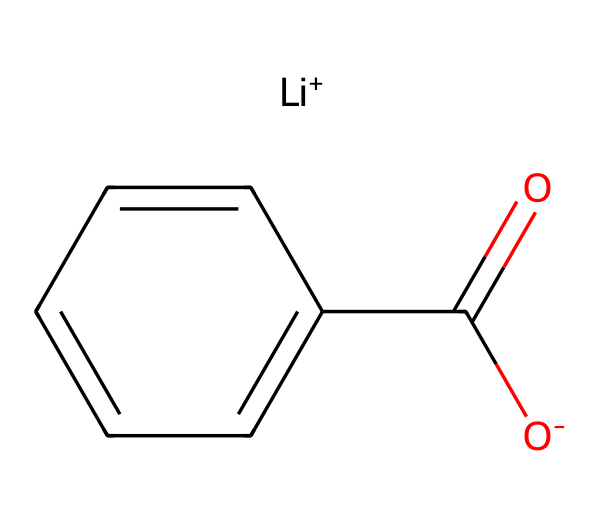How many lithium atoms are present in this structure? The SMILES notation directly indicates the presence of one lithium atom through the symbol [Li+]. There are no other lithium symbols indicated, confirming just one lithium in the structure.
Answer: one What is the oxidation state of lithium in this compound? In the provided SMILES, lithium is represented as [Li+], showing that it has a positive charge. This indicates that lithium has lost an electron and is in the +1 oxidation state.
Answer: +1 What functional group is present in this chemical structure? The chemical has the notation "C(=O)C", which indicates a carbonyl functional group (the C=O connection). Hence, the compound can be identified as containing a carboxylic acid or an ester functional group depending on the remaining structure.
Answer: carbonyl What type of bonding is indicated by the "C=O" notation? The "C=O" notation indicates a double bond between carbon and oxygen, which is characteristic of a carbonyl bond. Double bonds are stronger than single ones and indicate a specific reactivity in organic compounds, especially in oxidation reactions.
Answer: double bond What is the molecular formula of this compound? To derive the molecular formula, count the number of each type of atom present in the structure. The inclusion of [Li+], and the carbonyl indicates C and O atoms. By counting, we deduce a molecular formula, which includes 9 carbon (C), 10 hydrogen (H), 1 oxygen (O), and 1 lithium (Li).
Answer: C9H10LiO What type of battery does lithium primarily support in this structure? The molecular arrangement and the presence of lithium suggests it is used in lithium-ion batteries, which commonly employ lithium salts and carboxylate groups due to their electrochemical properties.
Answer: lithium-ion What property of lithium contributes to its use in batteries? Lithium has a low atomic mass and standard potential, making it highly reactive and favorable for batteries as it provides a high energy density and light weight in comparison to other metals.
Answer: high reactivity 